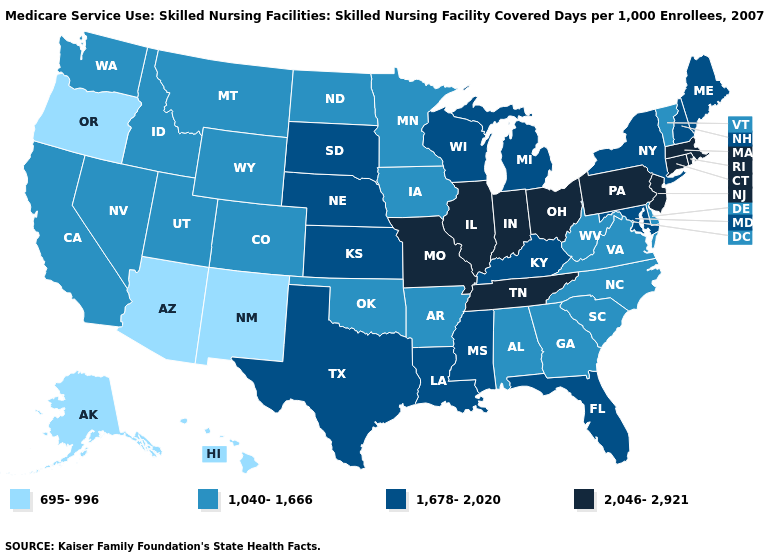Does New Mexico have the lowest value in the USA?
Keep it brief. Yes. Among the states that border Texas , does Louisiana have the highest value?
Give a very brief answer. Yes. Name the states that have a value in the range 2,046-2,921?
Be succinct. Connecticut, Illinois, Indiana, Massachusetts, Missouri, New Jersey, Ohio, Pennsylvania, Rhode Island, Tennessee. Name the states that have a value in the range 1,678-2,020?
Answer briefly. Florida, Kansas, Kentucky, Louisiana, Maine, Maryland, Michigan, Mississippi, Nebraska, New Hampshire, New York, South Dakota, Texas, Wisconsin. Does the map have missing data?
Answer briefly. No. What is the lowest value in the South?
Answer briefly. 1,040-1,666. Name the states that have a value in the range 695-996?
Short answer required. Alaska, Arizona, Hawaii, New Mexico, Oregon. Does Hawaii have the same value as New Mexico?
Answer briefly. Yes. Name the states that have a value in the range 1,678-2,020?
Write a very short answer. Florida, Kansas, Kentucky, Louisiana, Maine, Maryland, Michigan, Mississippi, Nebraska, New Hampshire, New York, South Dakota, Texas, Wisconsin. What is the lowest value in the USA?
Give a very brief answer. 695-996. What is the lowest value in the West?
Answer briefly. 695-996. Which states hav the highest value in the MidWest?
Short answer required. Illinois, Indiana, Missouri, Ohio. What is the value of North Dakota?
Write a very short answer. 1,040-1,666. Name the states that have a value in the range 1,678-2,020?
Give a very brief answer. Florida, Kansas, Kentucky, Louisiana, Maine, Maryland, Michigan, Mississippi, Nebraska, New Hampshire, New York, South Dakota, Texas, Wisconsin. What is the value of New Mexico?
Keep it brief. 695-996. 